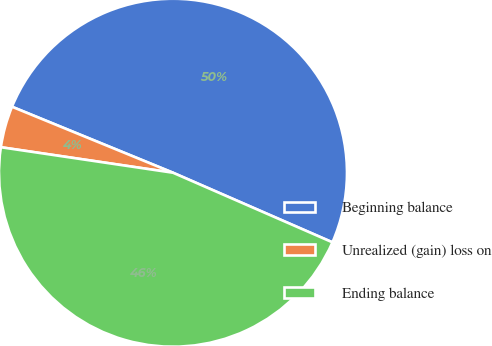<chart> <loc_0><loc_0><loc_500><loc_500><pie_chart><fcel>Beginning balance<fcel>Unrealized (gain) loss on<fcel>Ending balance<nl><fcel>50.36%<fcel>3.85%<fcel>45.79%<nl></chart> 